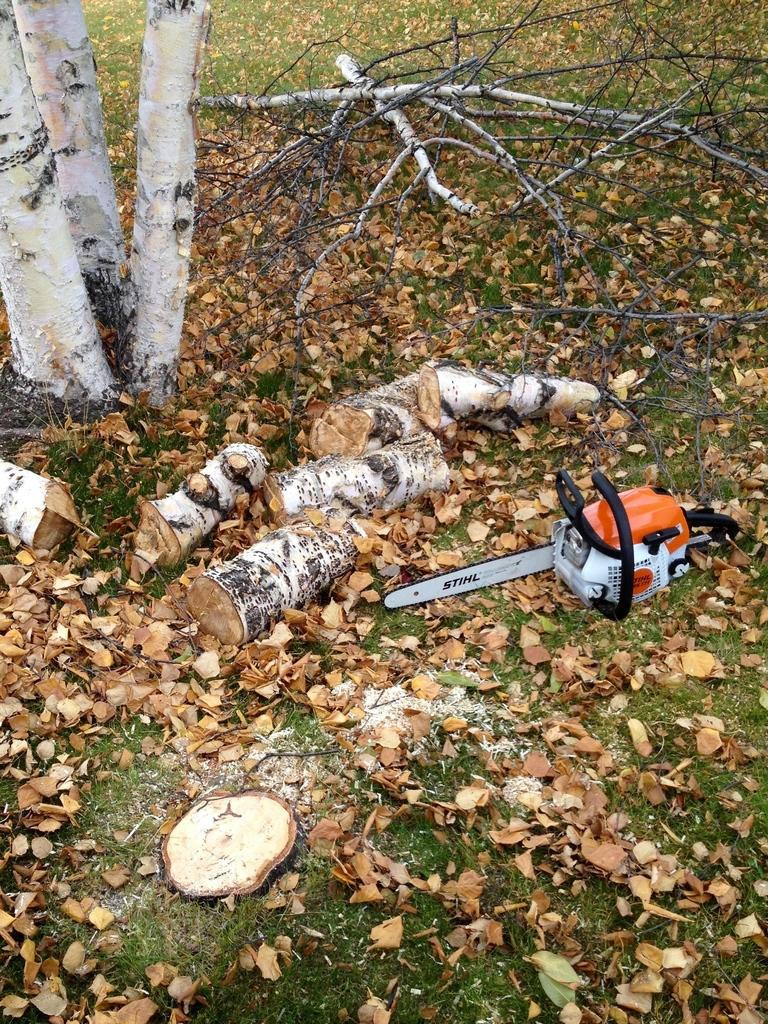What is the main object on the ground in the image? The facts do not specify the type of object on the ground. What can be seen in the background of the image? Tree branches and leaves are visible in the background of the image. How does the object on the ground kick the ball in the image? The facts do not mention a ball or any kicking action in the image. 